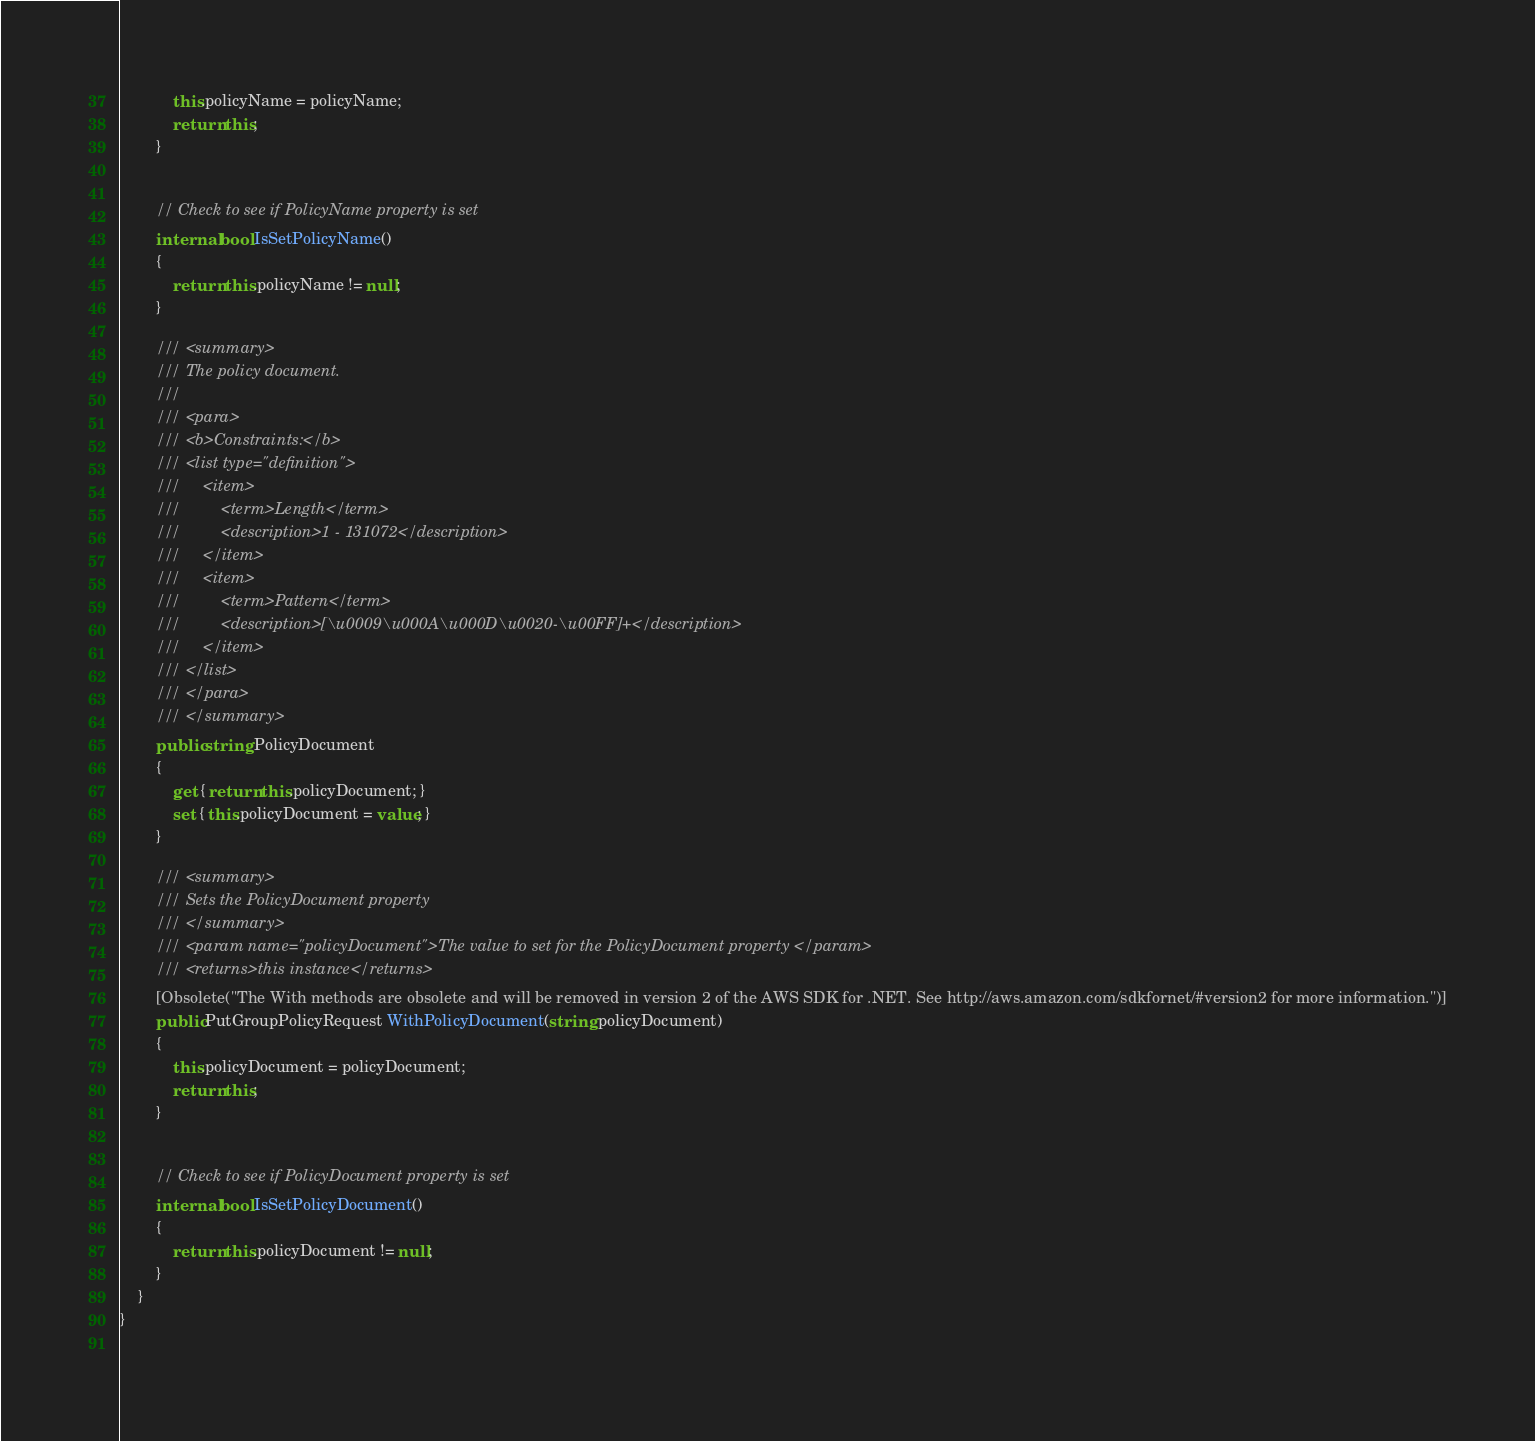<code> <loc_0><loc_0><loc_500><loc_500><_C#_>            this.policyName = policyName;
            return this;
        }
            

        // Check to see if PolicyName property is set
        internal bool IsSetPolicyName()
        {
            return this.policyName != null;
        }

        /// <summary>
        /// The policy document.
        ///  
        /// <para>
        /// <b>Constraints:</b>
        /// <list type="definition">
        ///     <item>
        ///         <term>Length</term>
        ///         <description>1 - 131072</description>
        ///     </item>
        ///     <item>
        ///         <term>Pattern</term>
        ///         <description>[\u0009\u000A\u000D\u0020-\u00FF]+</description>
        ///     </item>
        /// </list>
        /// </para>
        /// </summary>
        public string PolicyDocument
        {
            get { return this.policyDocument; }
            set { this.policyDocument = value; }
        }

        /// <summary>
        /// Sets the PolicyDocument property
        /// </summary>
        /// <param name="policyDocument">The value to set for the PolicyDocument property </param>
        /// <returns>this instance</returns>
        [Obsolete("The With methods are obsolete and will be removed in version 2 of the AWS SDK for .NET. See http://aws.amazon.com/sdkfornet/#version2 for more information.")]
        public PutGroupPolicyRequest WithPolicyDocument(string policyDocument)
        {
            this.policyDocument = policyDocument;
            return this;
        }
            

        // Check to see if PolicyDocument property is set
        internal bool IsSetPolicyDocument()
        {
            return this.policyDocument != null;
        }
    }
}
    
</code> 